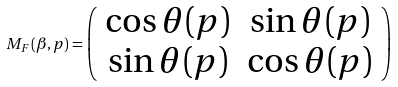<formula> <loc_0><loc_0><loc_500><loc_500>M _ { F } ( \beta , p ) = \left ( \begin{array} { c c } \cos \theta ( p ) & \sin \theta ( p ) \\ \sin \theta ( p ) & \cos \theta ( p ) \end{array} \right )</formula> 